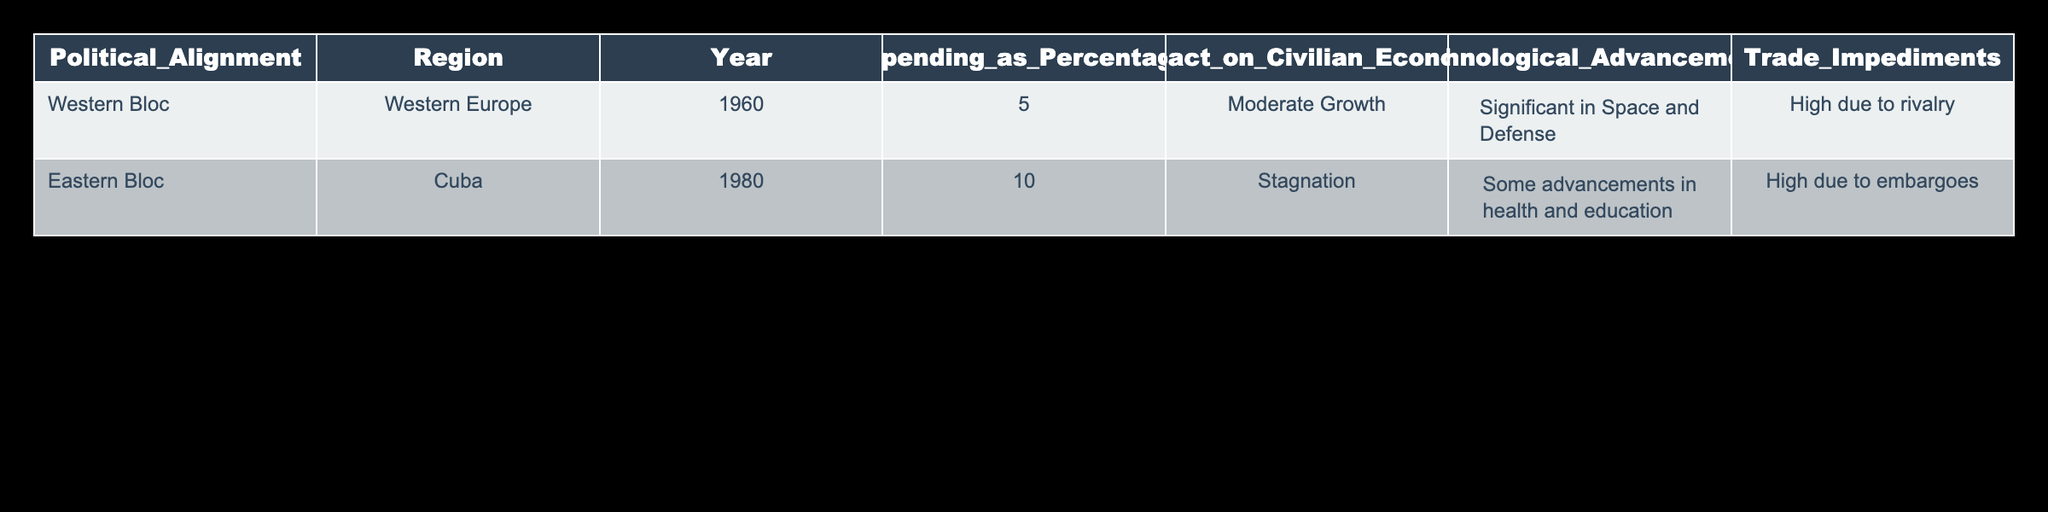What is the military spending as a percentage of GDP for the Western Bloc in 1960? According to the table, the military spending as a percentage of GDP for the Western Bloc in 1960 is 5.0.
Answer: 5.0 What was the impact on the civilian economy in Cuba during the Eastern Bloc's alignment in 1980? The table states that the impact on the civilian economy in Cuba during this period was "Stagnation."
Answer: Stagnation Was there significant technological advancement in the Western Bloc during the Cold War? The table indicates that there were "Significant" advancements in space and defense for the Western Bloc in 1960, which suggests yes.
Answer: Yes Which region had a higher percentage of military spending as a percentage of GDP: the Western Bloc or the Eastern Bloc? The Western Bloc had military spending of 5.0% in 1960, while the Eastern Bloc (Cuba) had 10.0% in 1980, indicating that the Eastern Bloc had higher military spending.
Answer: Eastern Bloc What trade impediments did the Eastern Bloc experience in 1980? The table notes that the trade impediments for the Eastern Bloc in 1980 were "High due to embargoes."
Answer: High due to embargoes Calculate the average military spending percentage from the two regions listed. The military spending percentages provided are 5.0 for the Western Bloc and 10.0 for the Eastern Bloc. Adding these values gives 15.0, and dividing by 2 yields an average of 7.5.
Answer: 7.5 Was technological advancement focused more on health and education in the Eastern Bloc during the Cold War? The table shows that the technological advancements in the Eastern Bloc (Cuba) were described as "Some advancements in health and education," which implies there were some advancements but not extensive focus.
Answer: No How did the civilian economy of Western Europe compare to that of Cuba regarding growth? The table indicates "Moderate Growth" for the civilian economy in the Western Bloc (Western Europe) in 1960 while noting "Stagnation" for Cuba in 1980. This suggests that Western Europe experienced better economic performance than Cuba.
Answer: Western Europe had better economic performance What is the relationship between military spending and trade impediments for both political alignments? Military spending had a higher percentage of GDP in the Eastern Bloc (10.0%) with "High due to embargoes," while the Western Bloc had lower military spending (5.0%) with "High due to rivalry." This highlights that higher military spending in the Eastern Bloc corresponded with significant trade impediments.
Answer: Higher military spending in Eastern Bloc corresponded with significant trade impediments 